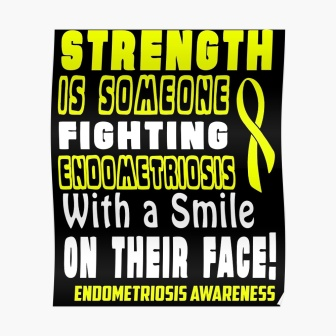What emotions might this poster evoke in someone who sees it daily? This poster is likely to evoke a mix of emotions. For someone fighting endometriosis, it could provide a sense of solidarity and strength, reminding them of their resilience. For others, it may evoke empathy and a desire to support those battling the condition. 